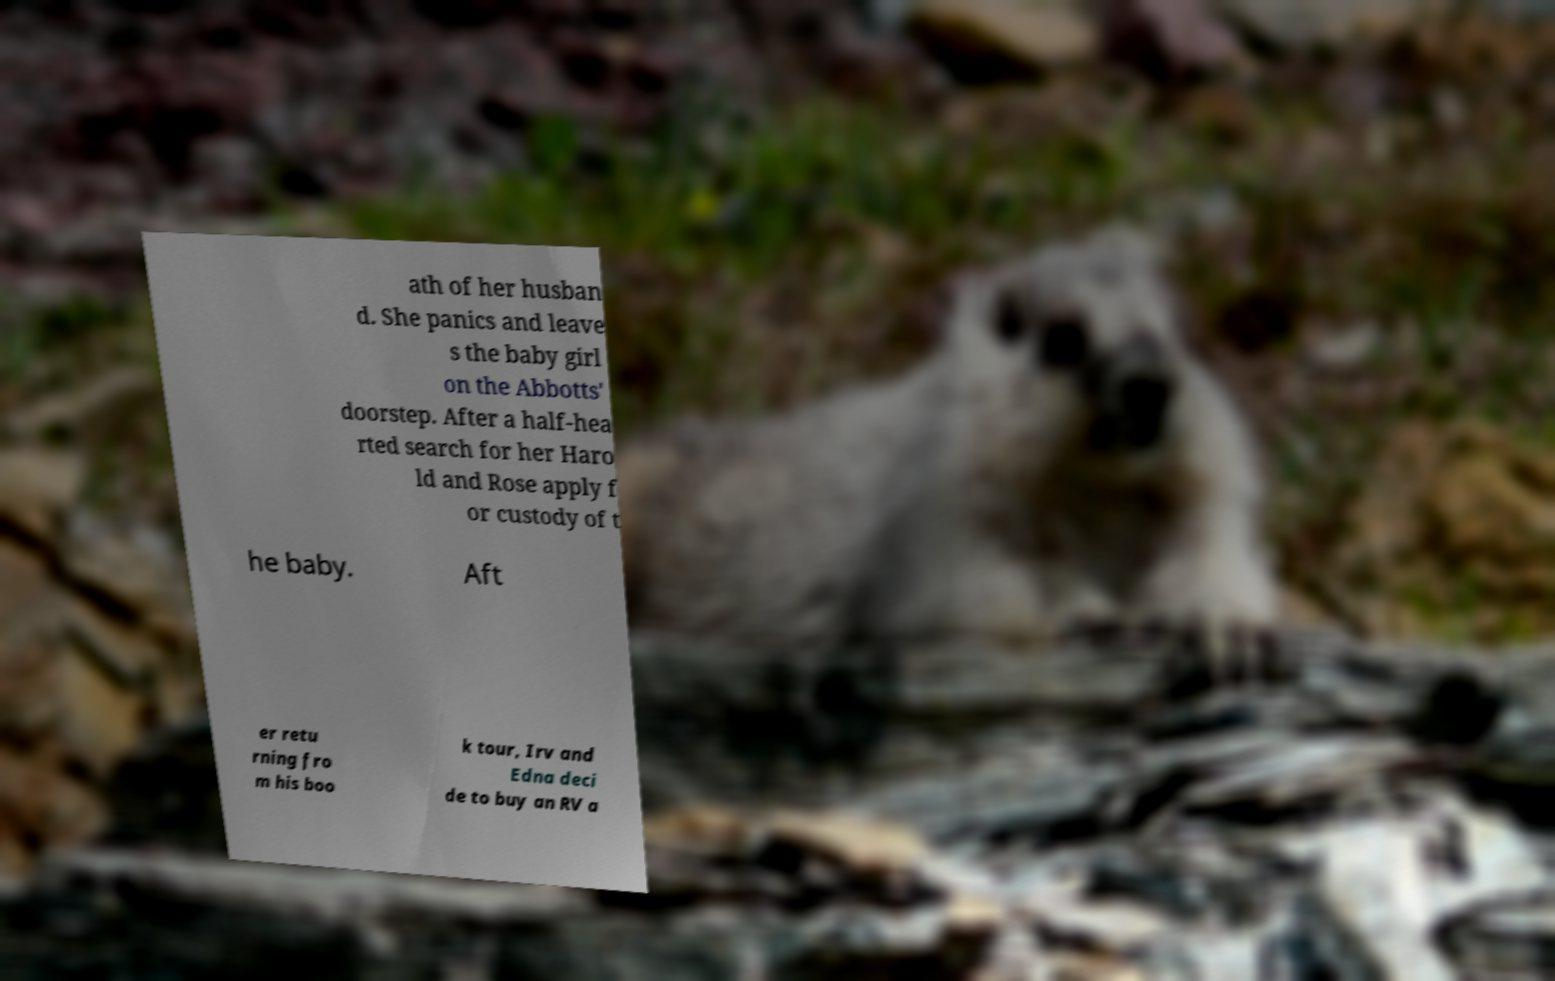Could you assist in decoding the text presented in this image and type it out clearly? ath of her husban d. She panics and leave s the baby girl on the Abbotts' doorstep. After a half-hea rted search for her Haro ld and Rose apply f or custody of t he baby. Aft er retu rning fro m his boo k tour, Irv and Edna deci de to buy an RV a 